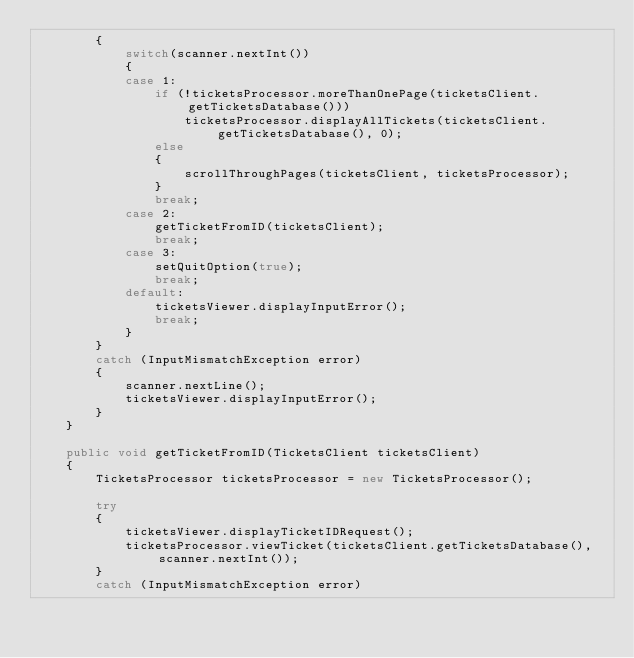<code> <loc_0><loc_0><loc_500><loc_500><_Java_>		{
			switch(scanner.nextInt())
			{
			case 1:
				if (!ticketsProcessor.moreThanOnePage(ticketsClient.getTicketsDatabase()))
					ticketsProcessor.displayAllTickets(ticketsClient.getTicketsDatabase(), 0);
				else
				{
					scrollThroughPages(ticketsClient, ticketsProcessor);
				}
				break;
			case 2:
				getTicketFromID(ticketsClient);
				break;
			case 3:
				setQuitOption(true);
				break;
			default:
				ticketsViewer.displayInputError();
				break;
			}
		}
		catch (InputMismatchException error)
		{
			scanner.nextLine();
			ticketsViewer.displayInputError();
		}
	}

	public void getTicketFromID(TicketsClient ticketsClient)
	{
		TicketsProcessor ticketsProcessor = new TicketsProcessor();
		
		try
		{
			ticketsViewer.displayTicketIDRequest();
			ticketsProcessor.viewTicket(ticketsClient.getTicketsDatabase(), scanner.nextInt());
		}
		catch (InputMismatchException error)</code> 